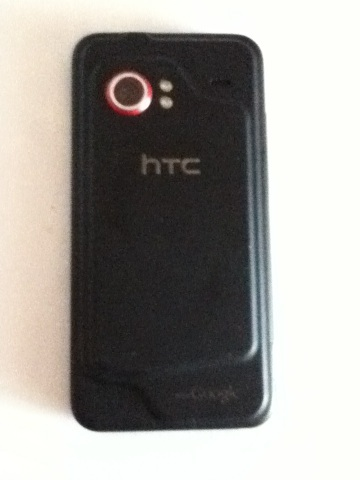What film is this? The image provided does not depict a scene from a film, but rather shows a black HTC smartphone, possibly the HTC Incredible model. The phone is characterized by its black casing and distinctive red circle around the camera lens. 